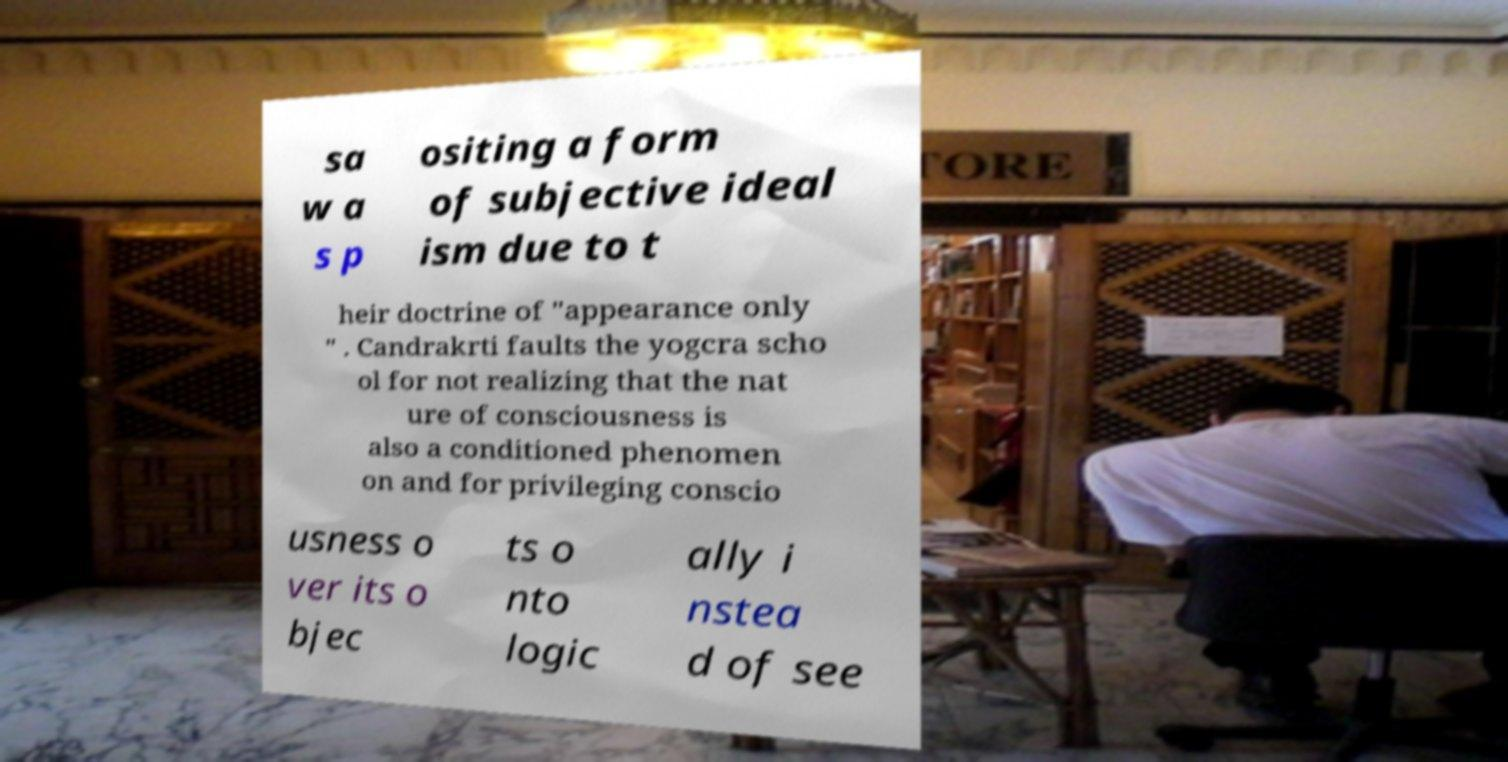Could you assist in decoding the text presented in this image and type it out clearly? sa w a s p ositing a form of subjective ideal ism due to t heir doctrine of "appearance only " . Candrakrti faults the yogcra scho ol for not realizing that the nat ure of consciousness is also a conditioned phenomen on and for privileging conscio usness o ver its o bjec ts o nto logic ally i nstea d of see 